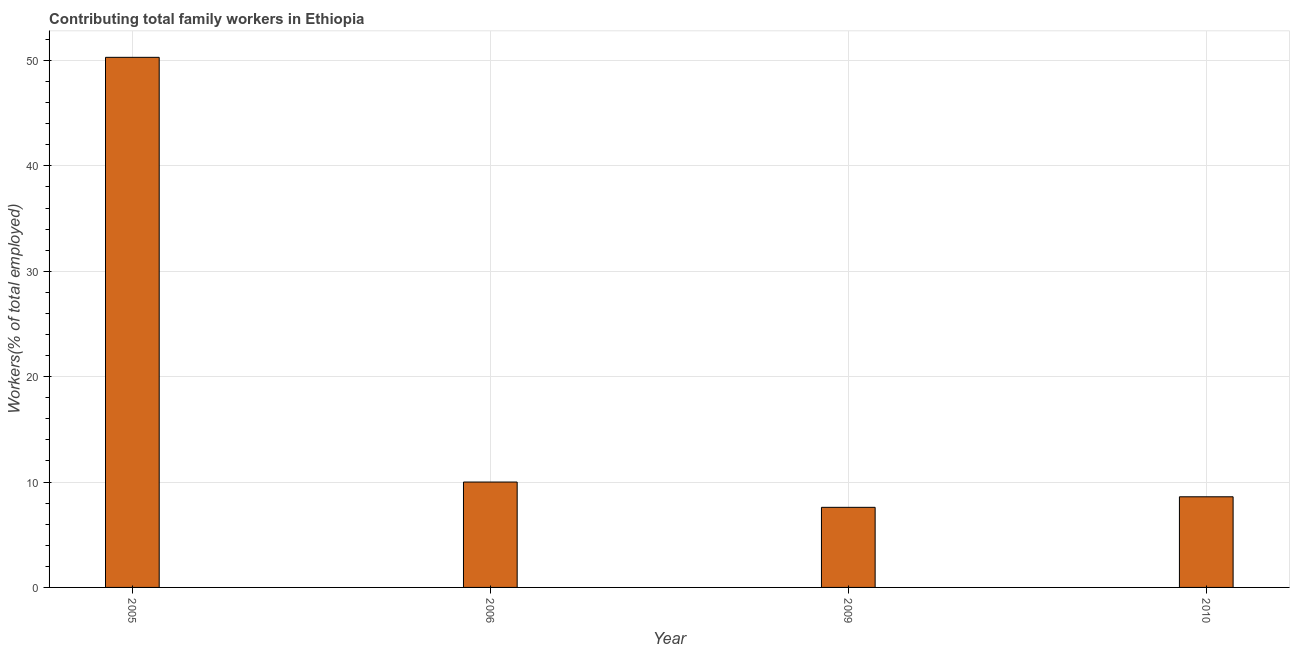Does the graph contain grids?
Ensure brevity in your answer.  Yes. What is the title of the graph?
Offer a very short reply. Contributing total family workers in Ethiopia. What is the label or title of the Y-axis?
Offer a terse response. Workers(% of total employed). What is the contributing family workers in 2006?
Your response must be concise. 10. Across all years, what is the maximum contributing family workers?
Offer a very short reply. 50.3. Across all years, what is the minimum contributing family workers?
Give a very brief answer. 7.6. In which year was the contributing family workers maximum?
Your answer should be compact. 2005. In which year was the contributing family workers minimum?
Provide a succinct answer. 2009. What is the sum of the contributing family workers?
Provide a succinct answer. 76.5. What is the difference between the contributing family workers in 2006 and 2009?
Your response must be concise. 2.4. What is the average contributing family workers per year?
Your response must be concise. 19.12. What is the median contributing family workers?
Make the answer very short. 9.3. What is the ratio of the contributing family workers in 2006 to that in 2009?
Give a very brief answer. 1.32. Is the difference between the contributing family workers in 2005 and 2009 greater than the difference between any two years?
Keep it short and to the point. Yes. What is the difference between the highest and the second highest contributing family workers?
Your answer should be very brief. 40.3. What is the difference between the highest and the lowest contributing family workers?
Keep it short and to the point. 42.7. How many bars are there?
Offer a very short reply. 4. Are all the bars in the graph horizontal?
Provide a short and direct response. No. What is the Workers(% of total employed) in 2005?
Ensure brevity in your answer.  50.3. What is the Workers(% of total employed) of 2009?
Your answer should be very brief. 7.6. What is the Workers(% of total employed) in 2010?
Make the answer very short. 8.6. What is the difference between the Workers(% of total employed) in 2005 and 2006?
Your answer should be very brief. 40.3. What is the difference between the Workers(% of total employed) in 2005 and 2009?
Offer a terse response. 42.7. What is the difference between the Workers(% of total employed) in 2005 and 2010?
Ensure brevity in your answer.  41.7. What is the difference between the Workers(% of total employed) in 2006 and 2009?
Provide a succinct answer. 2.4. What is the difference between the Workers(% of total employed) in 2006 and 2010?
Keep it short and to the point. 1.4. What is the difference between the Workers(% of total employed) in 2009 and 2010?
Ensure brevity in your answer.  -1. What is the ratio of the Workers(% of total employed) in 2005 to that in 2006?
Offer a very short reply. 5.03. What is the ratio of the Workers(% of total employed) in 2005 to that in 2009?
Provide a short and direct response. 6.62. What is the ratio of the Workers(% of total employed) in 2005 to that in 2010?
Ensure brevity in your answer.  5.85. What is the ratio of the Workers(% of total employed) in 2006 to that in 2009?
Your answer should be very brief. 1.32. What is the ratio of the Workers(% of total employed) in 2006 to that in 2010?
Your answer should be compact. 1.16. What is the ratio of the Workers(% of total employed) in 2009 to that in 2010?
Provide a succinct answer. 0.88. 